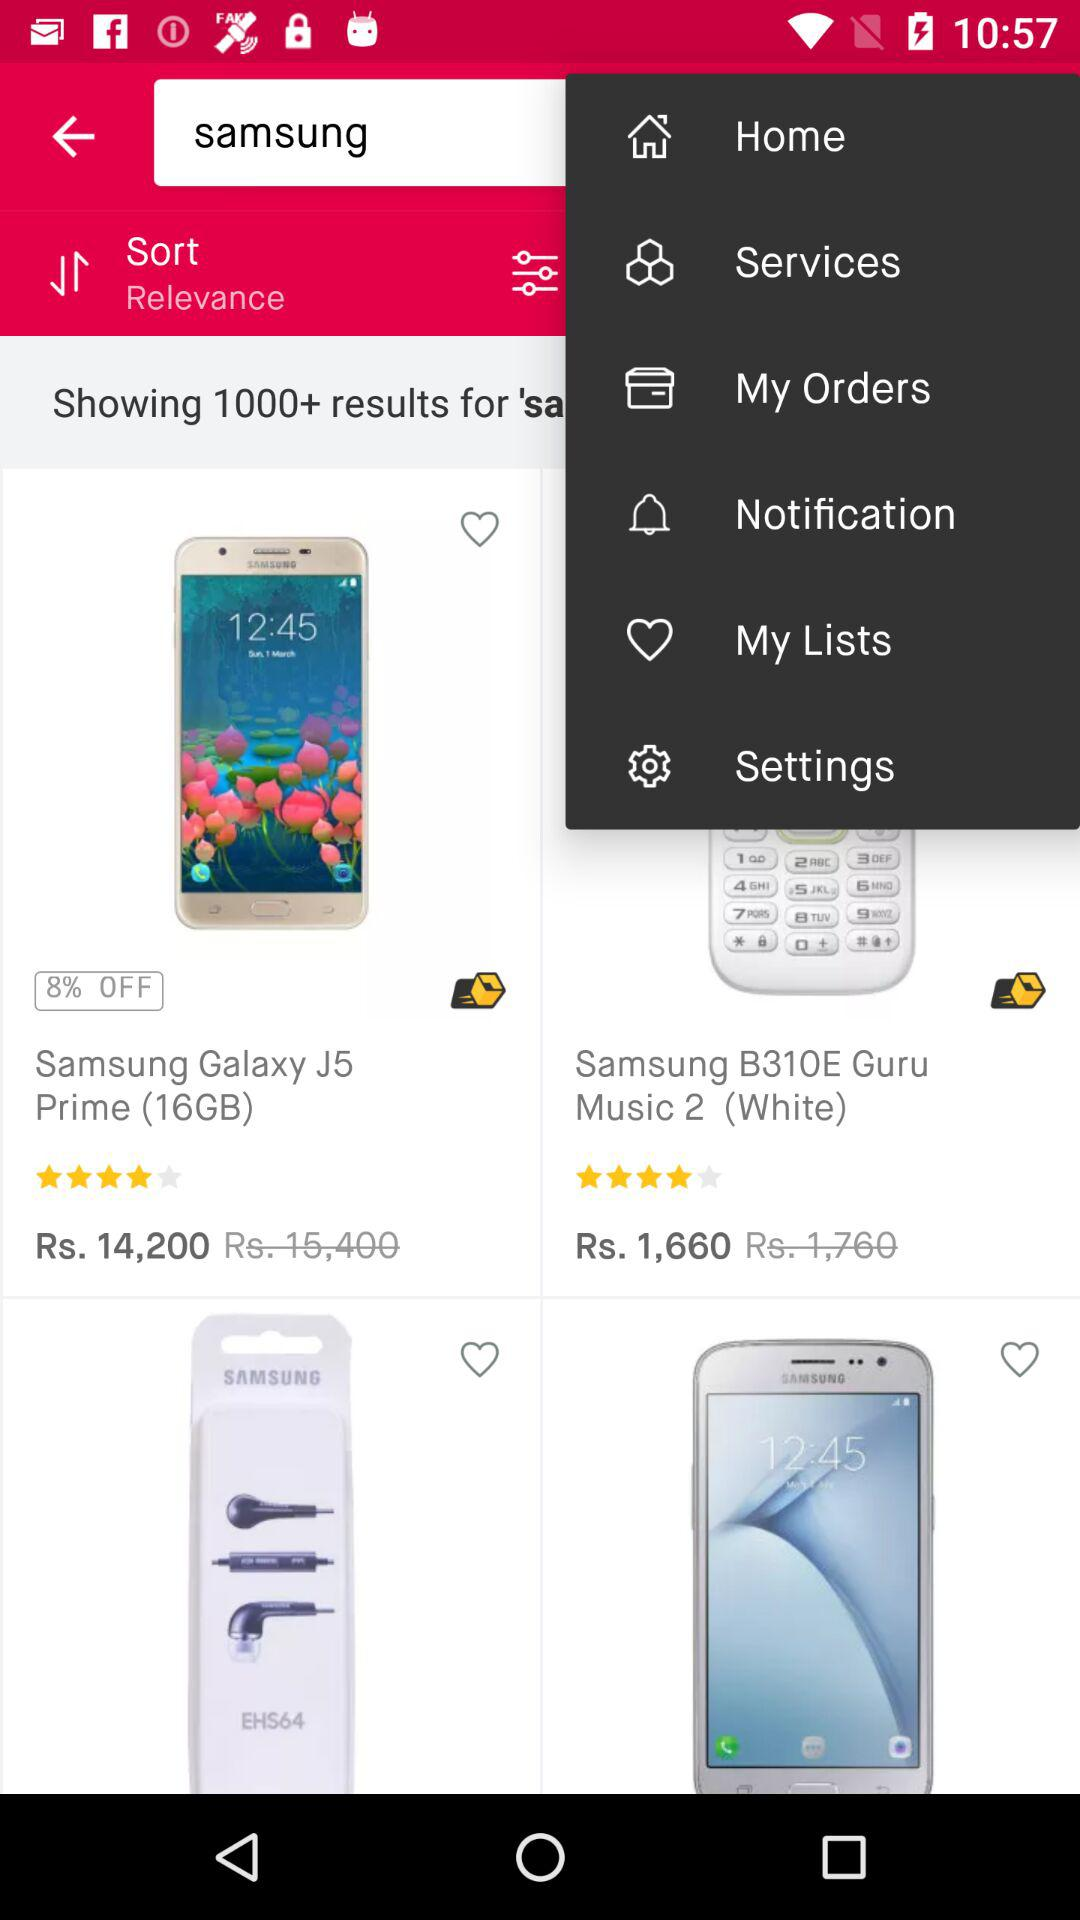How many items have a price of less than Rs. 15,000?
Answer the question using a single word or phrase. 2 